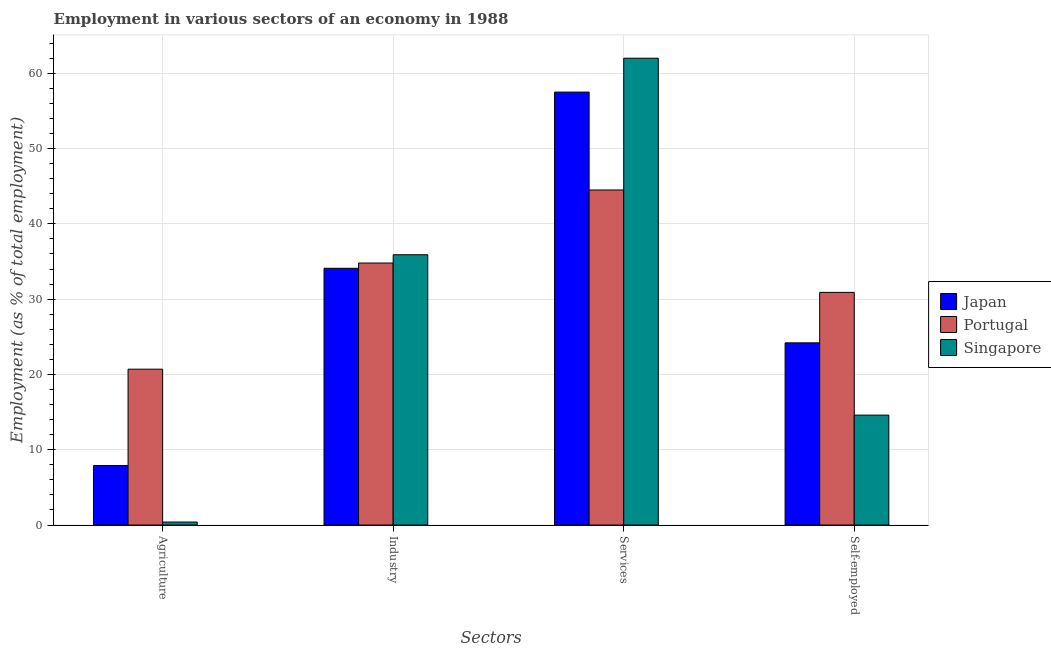How many groups of bars are there?
Give a very brief answer. 4. What is the label of the 2nd group of bars from the left?
Provide a short and direct response. Industry. What is the percentage of workers in agriculture in Singapore?
Provide a succinct answer. 0.4. Across all countries, what is the maximum percentage of workers in industry?
Your response must be concise. 35.9. Across all countries, what is the minimum percentage of self employed workers?
Keep it short and to the point. 14.6. In which country was the percentage of workers in industry maximum?
Offer a terse response. Singapore. What is the total percentage of workers in industry in the graph?
Your response must be concise. 104.8. What is the difference between the percentage of workers in agriculture in Japan and that in Singapore?
Provide a short and direct response. 7.5. What is the difference between the percentage of workers in agriculture in Japan and the percentage of self employed workers in Portugal?
Make the answer very short. -23. What is the average percentage of workers in agriculture per country?
Offer a terse response. 9.67. What is the difference between the percentage of workers in agriculture and percentage of workers in industry in Singapore?
Provide a succinct answer. -35.5. What is the ratio of the percentage of workers in agriculture in Japan to that in Singapore?
Your response must be concise. 19.75. Is the difference between the percentage of workers in agriculture in Portugal and Singapore greater than the difference between the percentage of workers in industry in Portugal and Singapore?
Make the answer very short. Yes. What is the difference between the highest and the second highest percentage of workers in industry?
Give a very brief answer. 1.1. What is the difference between the highest and the lowest percentage of self employed workers?
Your response must be concise. 16.3. In how many countries, is the percentage of workers in services greater than the average percentage of workers in services taken over all countries?
Make the answer very short. 2. Is the sum of the percentage of workers in industry in Japan and Portugal greater than the maximum percentage of workers in agriculture across all countries?
Your answer should be compact. Yes. What does the 3rd bar from the left in Services represents?
Give a very brief answer. Singapore. What does the 3rd bar from the right in Agriculture represents?
Your response must be concise. Japan. Is it the case that in every country, the sum of the percentage of workers in agriculture and percentage of workers in industry is greater than the percentage of workers in services?
Ensure brevity in your answer.  No. How many bars are there?
Your answer should be very brief. 12. How many countries are there in the graph?
Offer a terse response. 3. What is the difference between two consecutive major ticks on the Y-axis?
Offer a very short reply. 10. Are the values on the major ticks of Y-axis written in scientific E-notation?
Make the answer very short. No. Does the graph contain grids?
Ensure brevity in your answer.  Yes. How many legend labels are there?
Keep it short and to the point. 3. How are the legend labels stacked?
Provide a short and direct response. Vertical. What is the title of the graph?
Make the answer very short. Employment in various sectors of an economy in 1988. Does "Northern Mariana Islands" appear as one of the legend labels in the graph?
Provide a short and direct response. No. What is the label or title of the X-axis?
Offer a terse response. Sectors. What is the label or title of the Y-axis?
Make the answer very short. Employment (as % of total employment). What is the Employment (as % of total employment) of Japan in Agriculture?
Keep it short and to the point. 7.9. What is the Employment (as % of total employment) of Portugal in Agriculture?
Offer a very short reply. 20.7. What is the Employment (as % of total employment) of Singapore in Agriculture?
Offer a terse response. 0.4. What is the Employment (as % of total employment) of Japan in Industry?
Your answer should be very brief. 34.1. What is the Employment (as % of total employment) of Portugal in Industry?
Your answer should be compact. 34.8. What is the Employment (as % of total employment) in Singapore in Industry?
Offer a terse response. 35.9. What is the Employment (as % of total employment) of Japan in Services?
Make the answer very short. 57.5. What is the Employment (as % of total employment) in Portugal in Services?
Keep it short and to the point. 44.5. What is the Employment (as % of total employment) in Singapore in Services?
Your answer should be compact. 62. What is the Employment (as % of total employment) of Japan in Self-employed?
Offer a very short reply. 24.2. What is the Employment (as % of total employment) of Portugal in Self-employed?
Provide a succinct answer. 30.9. What is the Employment (as % of total employment) in Singapore in Self-employed?
Ensure brevity in your answer.  14.6. Across all Sectors, what is the maximum Employment (as % of total employment) of Japan?
Ensure brevity in your answer.  57.5. Across all Sectors, what is the maximum Employment (as % of total employment) of Portugal?
Keep it short and to the point. 44.5. Across all Sectors, what is the minimum Employment (as % of total employment) of Japan?
Your answer should be compact. 7.9. Across all Sectors, what is the minimum Employment (as % of total employment) in Portugal?
Offer a terse response. 20.7. Across all Sectors, what is the minimum Employment (as % of total employment) of Singapore?
Provide a short and direct response. 0.4. What is the total Employment (as % of total employment) of Japan in the graph?
Your answer should be very brief. 123.7. What is the total Employment (as % of total employment) in Portugal in the graph?
Give a very brief answer. 130.9. What is the total Employment (as % of total employment) in Singapore in the graph?
Your response must be concise. 112.9. What is the difference between the Employment (as % of total employment) in Japan in Agriculture and that in Industry?
Offer a terse response. -26.2. What is the difference between the Employment (as % of total employment) of Portugal in Agriculture and that in Industry?
Offer a very short reply. -14.1. What is the difference between the Employment (as % of total employment) of Singapore in Agriculture and that in Industry?
Your answer should be compact. -35.5. What is the difference between the Employment (as % of total employment) of Japan in Agriculture and that in Services?
Offer a terse response. -49.6. What is the difference between the Employment (as % of total employment) in Portugal in Agriculture and that in Services?
Offer a terse response. -23.8. What is the difference between the Employment (as % of total employment) in Singapore in Agriculture and that in Services?
Keep it short and to the point. -61.6. What is the difference between the Employment (as % of total employment) in Japan in Agriculture and that in Self-employed?
Your answer should be compact. -16.3. What is the difference between the Employment (as % of total employment) of Singapore in Agriculture and that in Self-employed?
Your answer should be compact. -14.2. What is the difference between the Employment (as % of total employment) of Japan in Industry and that in Services?
Offer a terse response. -23.4. What is the difference between the Employment (as % of total employment) in Portugal in Industry and that in Services?
Ensure brevity in your answer.  -9.7. What is the difference between the Employment (as % of total employment) in Singapore in Industry and that in Services?
Provide a short and direct response. -26.1. What is the difference between the Employment (as % of total employment) of Portugal in Industry and that in Self-employed?
Provide a short and direct response. 3.9. What is the difference between the Employment (as % of total employment) of Singapore in Industry and that in Self-employed?
Provide a short and direct response. 21.3. What is the difference between the Employment (as % of total employment) in Japan in Services and that in Self-employed?
Your answer should be very brief. 33.3. What is the difference between the Employment (as % of total employment) of Portugal in Services and that in Self-employed?
Your answer should be compact. 13.6. What is the difference between the Employment (as % of total employment) in Singapore in Services and that in Self-employed?
Offer a terse response. 47.4. What is the difference between the Employment (as % of total employment) in Japan in Agriculture and the Employment (as % of total employment) in Portugal in Industry?
Offer a very short reply. -26.9. What is the difference between the Employment (as % of total employment) in Japan in Agriculture and the Employment (as % of total employment) in Singapore in Industry?
Your answer should be very brief. -28. What is the difference between the Employment (as % of total employment) of Portugal in Agriculture and the Employment (as % of total employment) of Singapore in Industry?
Give a very brief answer. -15.2. What is the difference between the Employment (as % of total employment) of Japan in Agriculture and the Employment (as % of total employment) of Portugal in Services?
Provide a succinct answer. -36.6. What is the difference between the Employment (as % of total employment) in Japan in Agriculture and the Employment (as % of total employment) in Singapore in Services?
Your answer should be very brief. -54.1. What is the difference between the Employment (as % of total employment) in Portugal in Agriculture and the Employment (as % of total employment) in Singapore in Services?
Your answer should be very brief. -41.3. What is the difference between the Employment (as % of total employment) of Portugal in Agriculture and the Employment (as % of total employment) of Singapore in Self-employed?
Offer a terse response. 6.1. What is the difference between the Employment (as % of total employment) of Japan in Industry and the Employment (as % of total employment) of Portugal in Services?
Offer a terse response. -10.4. What is the difference between the Employment (as % of total employment) in Japan in Industry and the Employment (as % of total employment) in Singapore in Services?
Offer a very short reply. -27.9. What is the difference between the Employment (as % of total employment) of Portugal in Industry and the Employment (as % of total employment) of Singapore in Services?
Your response must be concise. -27.2. What is the difference between the Employment (as % of total employment) in Japan in Industry and the Employment (as % of total employment) in Singapore in Self-employed?
Provide a succinct answer. 19.5. What is the difference between the Employment (as % of total employment) in Portugal in Industry and the Employment (as % of total employment) in Singapore in Self-employed?
Your response must be concise. 20.2. What is the difference between the Employment (as % of total employment) in Japan in Services and the Employment (as % of total employment) in Portugal in Self-employed?
Ensure brevity in your answer.  26.6. What is the difference between the Employment (as % of total employment) in Japan in Services and the Employment (as % of total employment) in Singapore in Self-employed?
Give a very brief answer. 42.9. What is the difference between the Employment (as % of total employment) of Portugal in Services and the Employment (as % of total employment) of Singapore in Self-employed?
Give a very brief answer. 29.9. What is the average Employment (as % of total employment) in Japan per Sectors?
Your answer should be compact. 30.93. What is the average Employment (as % of total employment) in Portugal per Sectors?
Give a very brief answer. 32.73. What is the average Employment (as % of total employment) of Singapore per Sectors?
Provide a succinct answer. 28.23. What is the difference between the Employment (as % of total employment) of Portugal and Employment (as % of total employment) of Singapore in Agriculture?
Give a very brief answer. 20.3. What is the difference between the Employment (as % of total employment) of Japan and Employment (as % of total employment) of Singapore in Industry?
Provide a succinct answer. -1.8. What is the difference between the Employment (as % of total employment) in Portugal and Employment (as % of total employment) in Singapore in Industry?
Offer a terse response. -1.1. What is the difference between the Employment (as % of total employment) in Japan and Employment (as % of total employment) in Singapore in Services?
Your answer should be compact. -4.5. What is the difference between the Employment (as % of total employment) in Portugal and Employment (as % of total employment) in Singapore in Services?
Your answer should be compact. -17.5. What is the difference between the Employment (as % of total employment) in Japan and Employment (as % of total employment) in Singapore in Self-employed?
Make the answer very short. 9.6. What is the ratio of the Employment (as % of total employment) in Japan in Agriculture to that in Industry?
Ensure brevity in your answer.  0.23. What is the ratio of the Employment (as % of total employment) of Portugal in Agriculture to that in Industry?
Give a very brief answer. 0.59. What is the ratio of the Employment (as % of total employment) of Singapore in Agriculture to that in Industry?
Your answer should be compact. 0.01. What is the ratio of the Employment (as % of total employment) in Japan in Agriculture to that in Services?
Offer a terse response. 0.14. What is the ratio of the Employment (as % of total employment) in Portugal in Agriculture to that in Services?
Offer a very short reply. 0.47. What is the ratio of the Employment (as % of total employment) of Singapore in Agriculture to that in Services?
Keep it short and to the point. 0.01. What is the ratio of the Employment (as % of total employment) in Japan in Agriculture to that in Self-employed?
Your answer should be compact. 0.33. What is the ratio of the Employment (as % of total employment) of Portugal in Agriculture to that in Self-employed?
Give a very brief answer. 0.67. What is the ratio of the Employment (as % of total employment) in Singapore in Agriculture to that in Self-employed?
Provide a short and direct response. 0.03. What is the ratio of the Employment (as % of total employment) in Japan in Industry to that in Services?
Give a very brief answer. 0.59. What is the ratio of the Employment (as % of total employment) in Portugal in Industry to that in Services?
Ensure brevity in your answer.  0.78. What is the ratio of the Employment (as % of total employment) in Singapore in Industry to that in Services?
Your answer should be compact. 0.58. What is the ratio of the Employment (as % of total employment) of Japan in Industry to that in Self-employed?
Ensure brevity in your answer.  1.41. What is the ratio of the Employment (as % of total employment) of Portugal in Industry to that in Self-employed?
Your answer should be very brief. 1.13. What is the ratio of the Employment (as % of total employment) of Singapore in Industry to that in Self-employed?
Make the answer very short. 2.46. What is the ratio of the Employment (as % of total employment) in Japan in Services to that in Self-employed?
Your response must be concise. 2.38. What is the ratio of the Employment (as % of total employment) in Portugal in Services to that in Self-employed?
Offer a very short reply. 1.44. What is the ratio of the Employment (as % of total employment) of Singapore in Services to that in Self-employed?
Offer a very short reply. 4.25. What is the difference between the highest and the second highest Employment (as % of total employment) in Japan?
Your response must be concise. 23.4. What is the difference between the highest and the second highest Employment (as % of total employment) in Portugal?
Offer a terse response. 9.7. What is the difference between the highest and the second highest Employment (as % of total employment) of Singapore?
Provide a succinct answer. 26.1. What is the difference between the highest and the lowest Employment (as % of total employment) in Japan?
Offer a very short reply. 49.6. What is the difference between the highest and the lowest Employment (as % of total employment) in Portugal?
Provide a succinct answer. 23.8. What is the difference between the highest and the lowest Employment (as % of total employment) in Singapore?
Give a very brief answer. 61.6. 